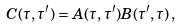<formula> <loc_0><loc_0><loc_500><loc_500>C ( \tau , \tau ^ { \prime } ) = A ( \tau , \tau ^ { \prime } ) B ( \tau ^ { \prime } , \tau ) \, ,</formula> 